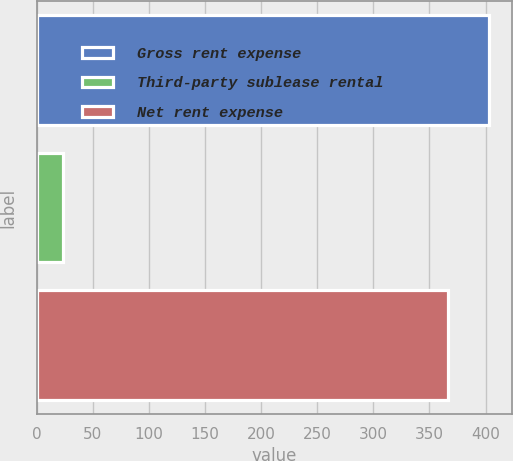<chart> <loc_0><loc_0><loc_500><loc_500><bar_chart><fcel>Gross rent expense<fcel>Third-party sublease rental<fcel>Net rent expense<nl><fcel>403.04<fcel>23.5<fcel>366.4<nl></chart> 